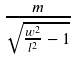<formula> <loc_0><loc_0><loc_500><loc_500>\frac { m } { \sqrt { \frac { w ^ { 2 } } { l ^ { 2 } } - 1 } }</formula> 